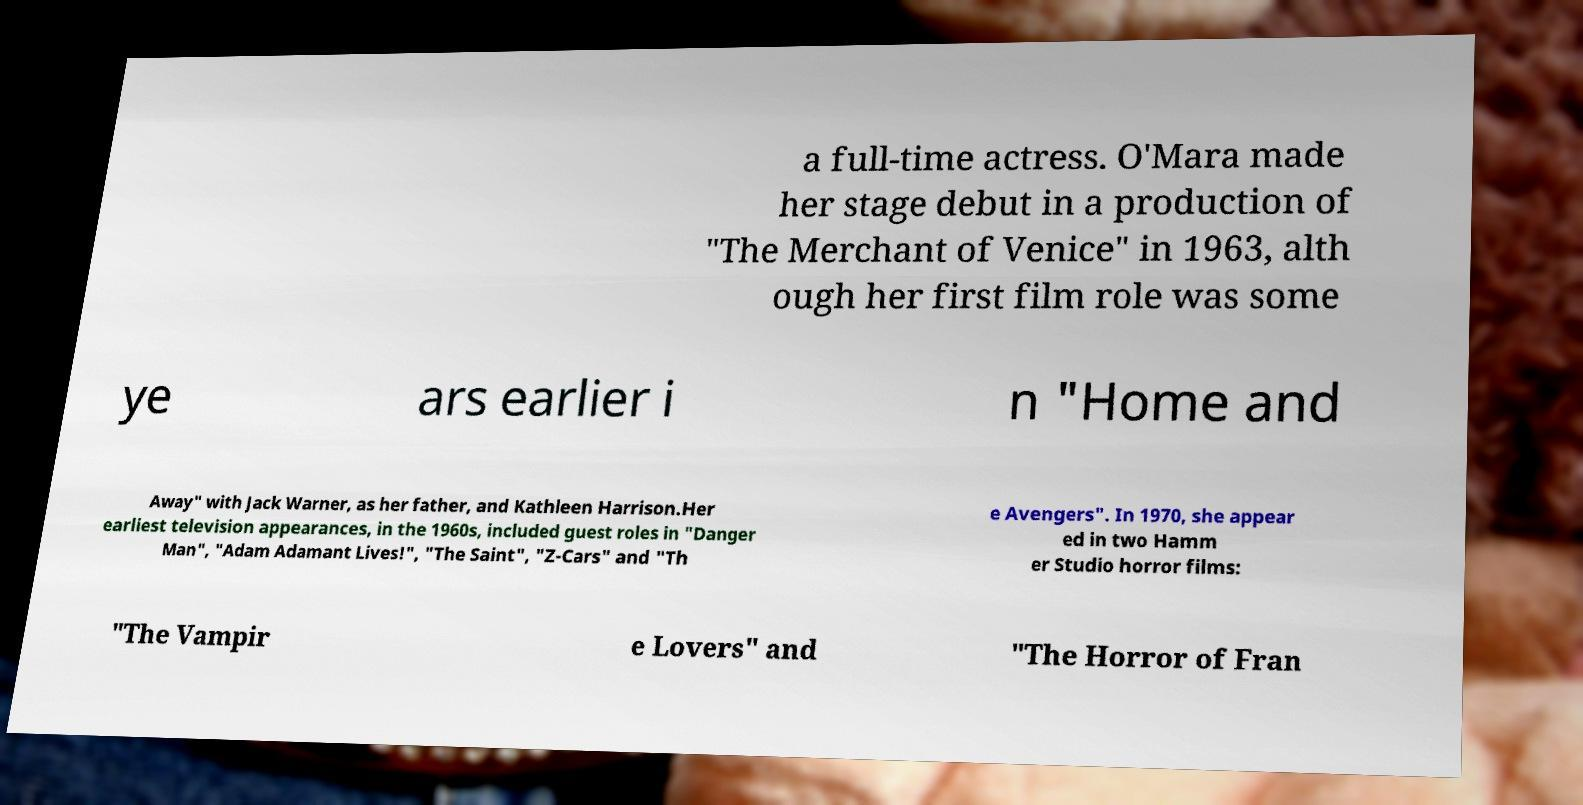Please read and relay the text visible in this image. What does it say? a full-time actress. O'Mara made her stage debut in a production of "The Merchant of Venice" in 1963, alth ough her first film role was some ye ars earlier i n "Home and Away" with Jack Warner, as her father, and Kathleen Harrison.Her earliest television appearances, in the 1960s, included guest roles in "Danger Man", "Adam Adamant Lives!", "The Saint", "Z-Cars" and "Th e Avengers". In 1970, she appear ed in two Hamm er Studio horror films: "The Vampir e Lovers" and "The Horror of Fran 